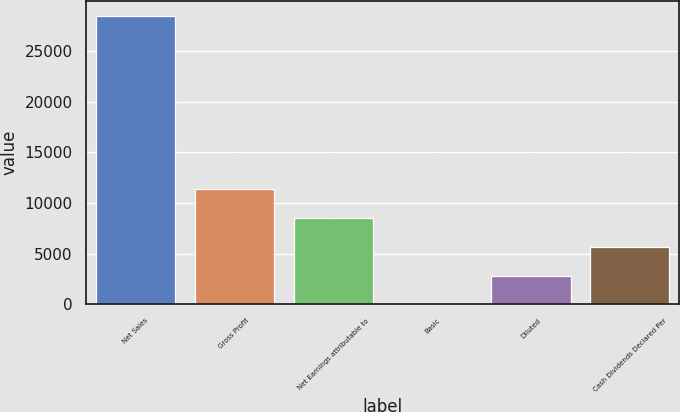<chart> <loc_0><loc_0><loc_500><loc_500><bar_chart><fcel>Net Sales<fcel>Gross Profit<fcel>Net Earnings attributable to<fcel>Basic<fcel>Diluted<fcel>Cash Dividends Declared Per<nl><fcel>28522<fcel>11408.8<fcel>8556.62<fcel>0.02<fcel>2852.22<fcel>5704.42<nl></chart> 